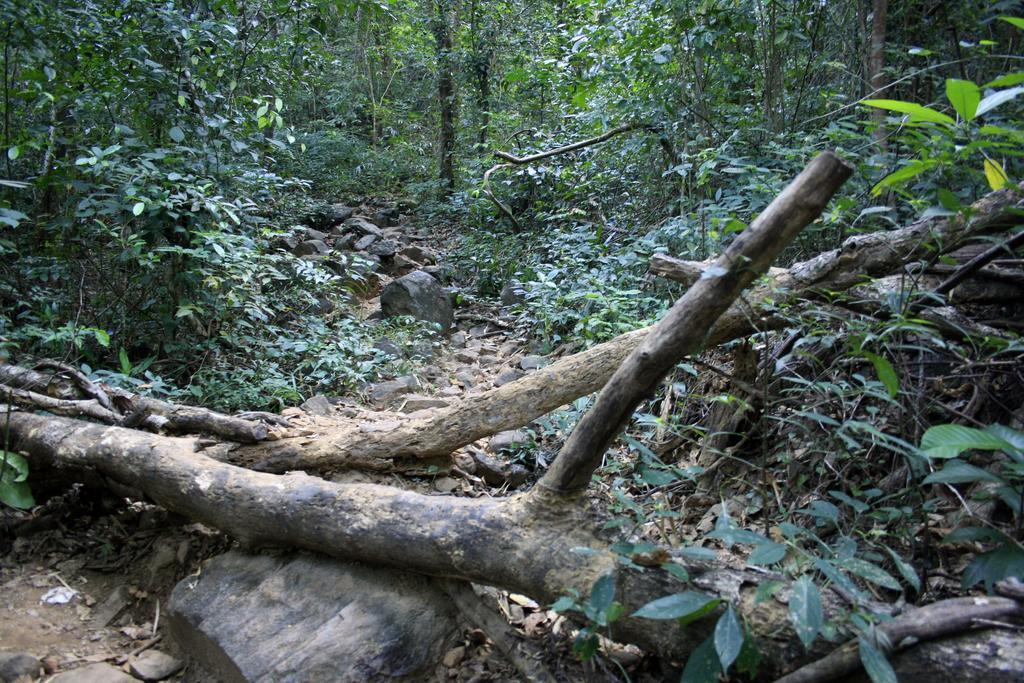What type of vegetation can be seen in the image? There are trees and plants in the image. What material is present in the image? There is wood in the image. What type of natural elements can be seen in the image? There are stones in the image. How many jellyfish can be seen swimming in the image? There are no jellyfish present in the image; it features trees, plants, wood, and stones. 